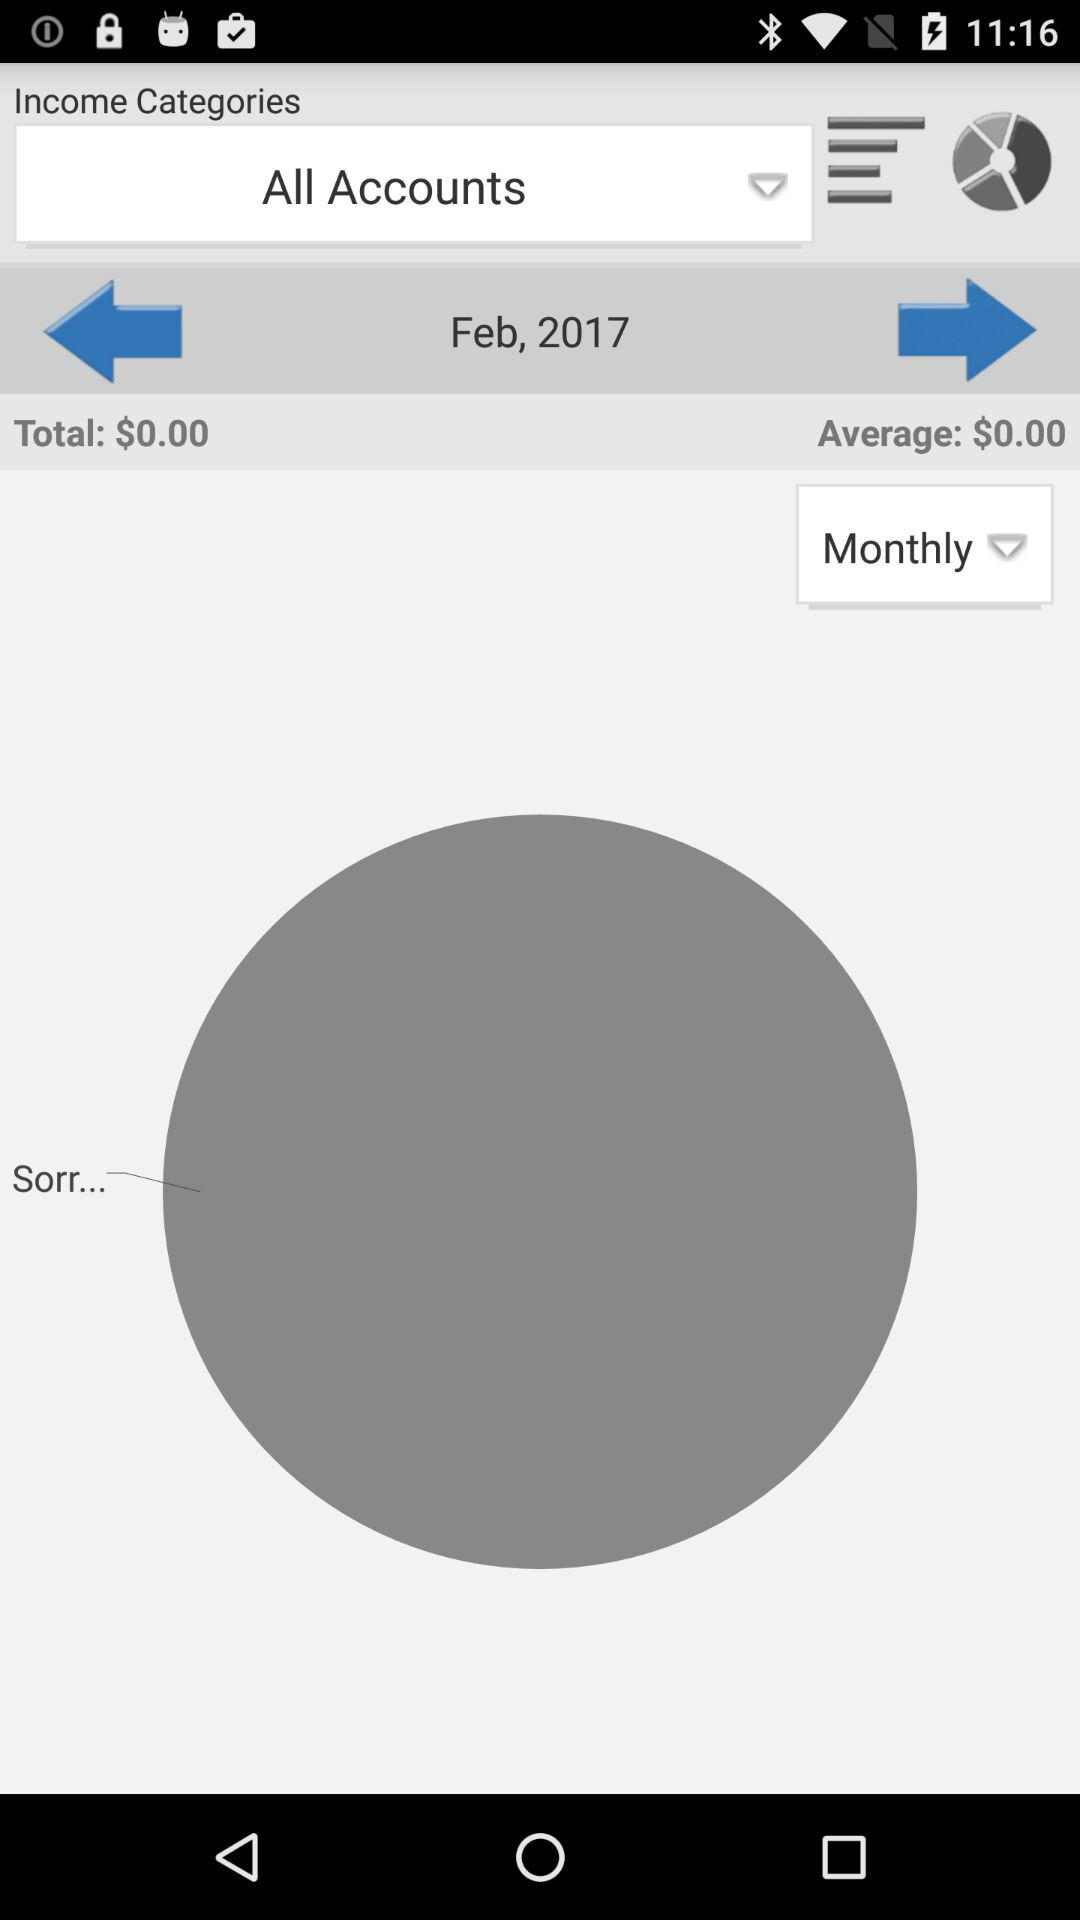How many months are shown in the chart?
Answer the question using a single word or phrase. 1 